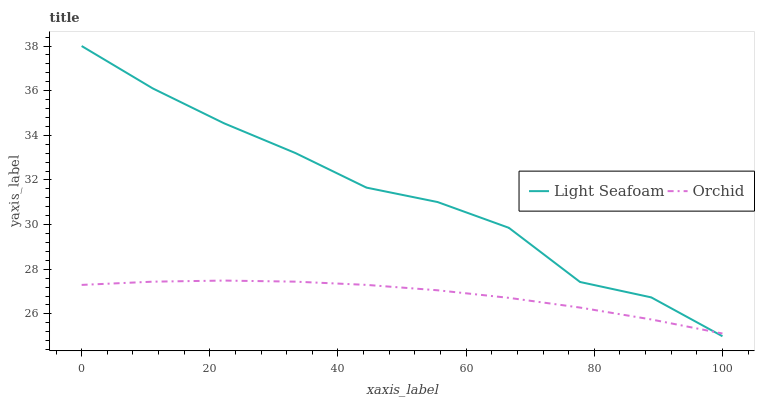Does Orchid have the minimum area under the curve?
Answer yes or no. Yes. Does Light Seafoam have the maximum area under the curve?
Answer yes or no. Yes. Does Orchid have the maximum area under the curve?
Answer yes or no. No. Is Orchid the smoothest?
Answer yes or no. Yes. Is Light Seafoam the roughest?
Answer yes or no. Yes. Is Orchid the roughest?
Answer yes or no. No. Does Orchid have the lowest value?
Answer yes or no. No. Does Light Seafoam have the highest value?
Answer yes or no. Yes. Does Orchid have the highest value?
Answer yes or no. No. Does Orchid intersect Light Seafoam?
Answer yes or no. Yes. Is Orchid less than Light Seafoam?
Answer yes or no. No. Is Orchid greater than Light Seafoam?
Answer yes or no. No. 